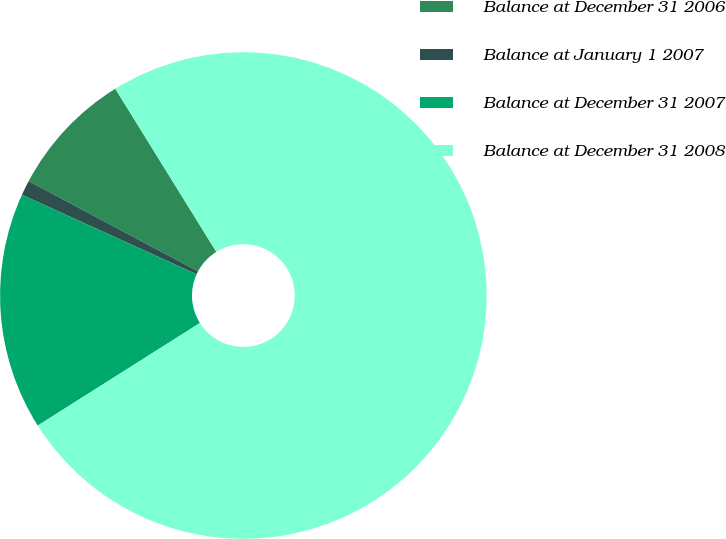Convert chart. <chart><loc_0><loc_0><loc_500><loc_500><pie_chart><fcel>Balance at December 31 2006<fcel>Balance at January 1 2007<fcel>Balance at December 31 2007<fcel>Balance at December 31 2008<nl><fcel>8.38%<fcel>1.0%<fcel>15.77%<fcel>74.85%<nl></chart> 